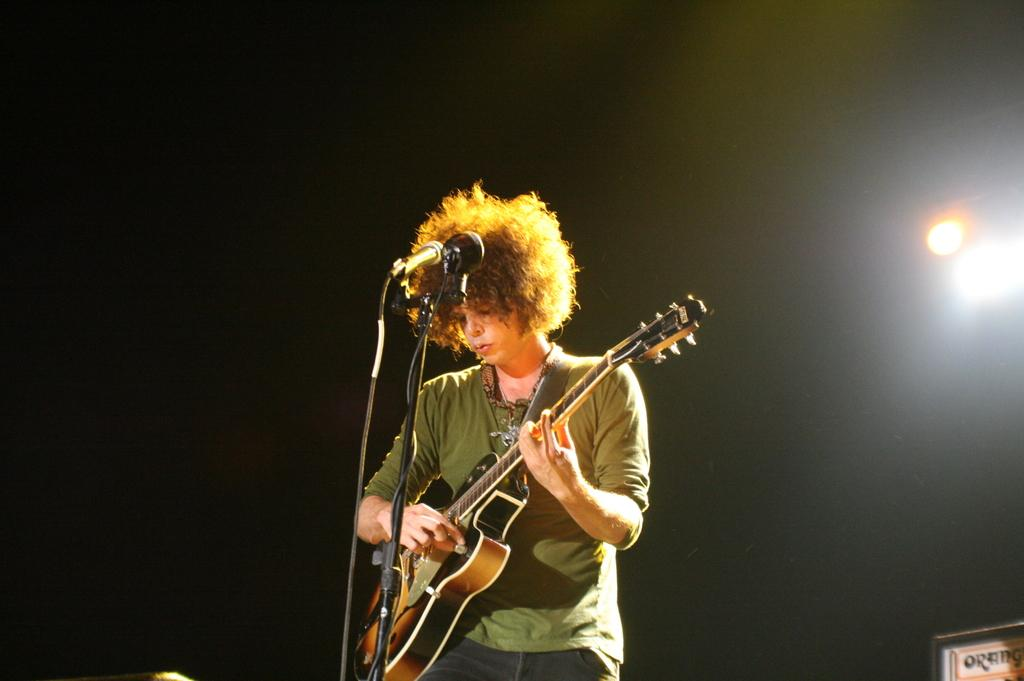What is the main subject of the image? There is a person in the image. What is the person wearing? The person is wearing clothes. What activity is the person engaged in? The person is playing a guitar. What object is in front of the person? The person is in front of a mic. What can be seen on the right side of the image? There is a light on the right side of the image. What type of care can be seen being provided to the star in the image? There is no star or care being provided in the image; it features a person playing a guitar in front of a mic. 